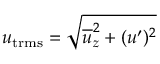<formula> <loc_0><loc_0><loc_500><loc_500>u _ { t r m s } = \sqrt { \overline { u } _ { z } ^ { 2 } + ( u ^ { \prime } ) ^ { 2 } }</formula> 